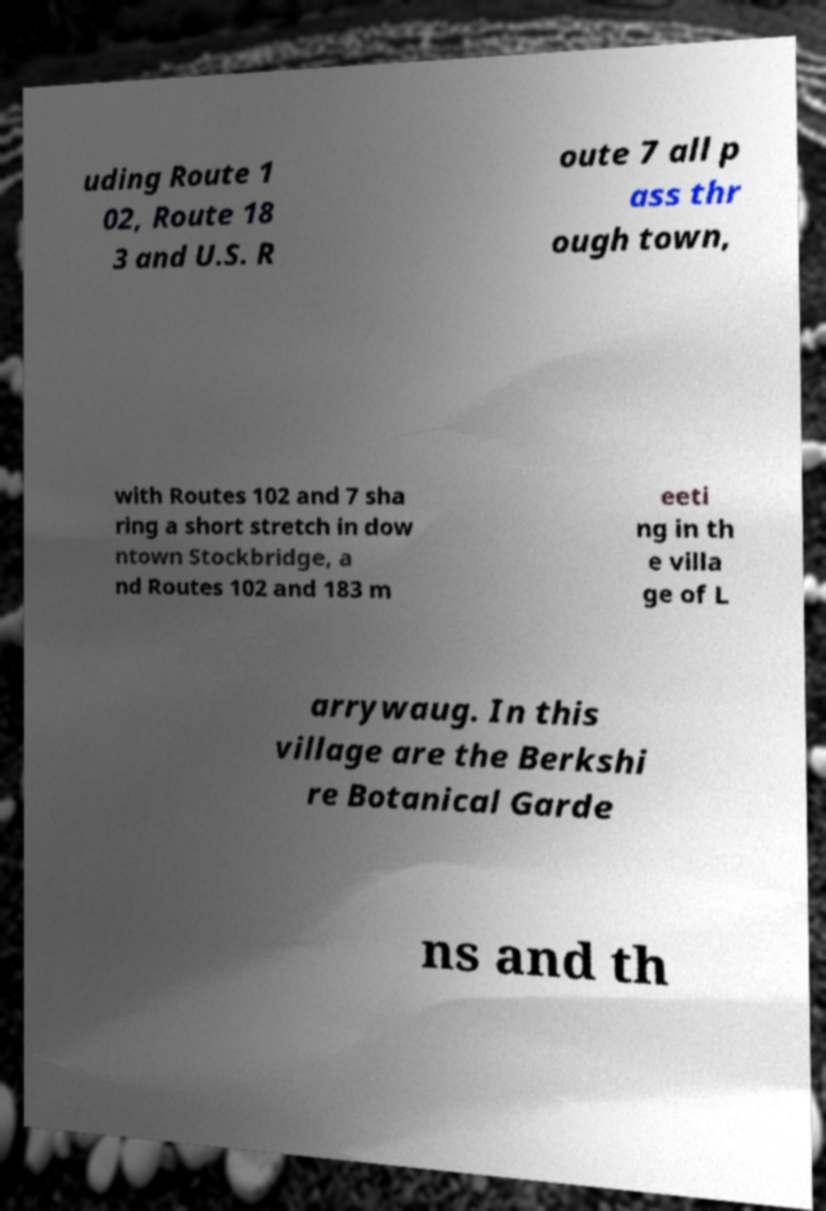Can you read and provide the text displayed in the image?This photo seems to have some interesting text. Can you extract and type it out for me? uding Route 1 02, Route 18 3 and U.S. R oute 7 all p ass thr ough town, with Routes 102 and 7 sha ring a short stretch in dow ntown Stockbridge, a nd Routes 102 and 183 m eeti ng in th e villa ge of L arrywaug. In this village are the Berkshi re Botanical Garde ns and th 